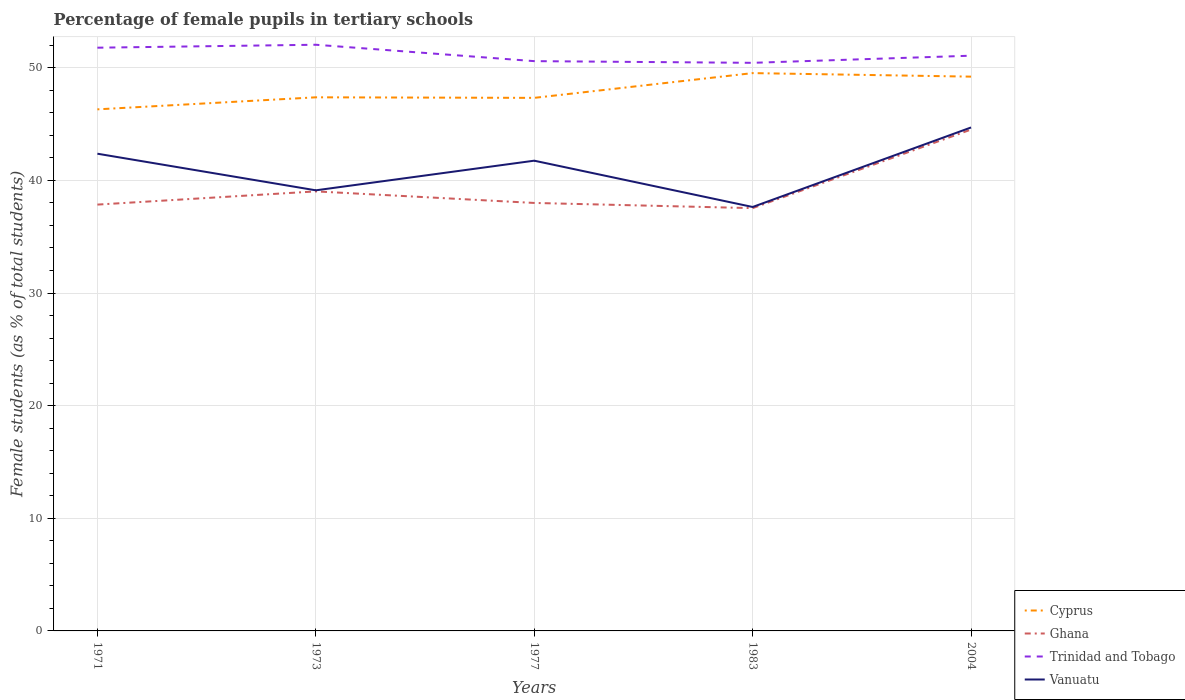Does the line corresponding to Ghana intersect with the line corresponding to Vanuatu?
Your response must be concise. No. Is the number of lines equal to the number of legend labels?
Your answer should be very brief. Yes. Across all years, what is the maximum percentage of female pupils in tertiary schools in Vanuatu?
Keep it short and to the point. 37.64. In which year was the percentage of female pupils in tertiary schools in Ghana maximum?
Give a very brief answer. 1983. What is the total percentage of female pupils in tertiary schools in Cyprus in the graph?
Give a very brief answer. -3.22. What is the difference between the highest and the second highest percentage of female pupils in tertiary schools in Trinidad and Tobago?
Make the answer very short. 1.6. What is the difference between the highest and the lowest percentage of female pupils in tertiary schools in Cyprus?
Provide a short and direct response. 2. Is the percentage of female pupils in tertiary schools in Cyprus strictly greater than the percentage of female pupils in tertiary schools in Ghana over the years?
Keep it short and to the point. No. Where does the legend appear in the graph?
Offer a terse response. Bottom right. What is the title of the graph?
Your answer should be compact. Percentage of female pupils in tertiary schools. Does "Least developed countries" appear as one of the legend labels in the graph?
Your answer should be compact. No. What is the label or title of the Y-axis?
Keep it short and to the point. Female students (as % of total students). What is the Female students (as % of total students) of Cyprus in 1971?
Provide a short and direct response. 46.31. What is the Female students (as % of total students) in Ghana in 1971?
Offer a very short reply. 37.85. What is the Female students (as % of total students) in Trinidad and Tobago in 1971?
Offer a very short reply. 51.78. What is the Female students (as % of total students) in Vanuatu in 1971?
Make the answer very short. 42.37. What is the Female students (as % of total students) of Cyprus in 1973?
Give a very brief answer. 47.38. What is the Female students (as % of total students) of Ghana in 1973?
Give a very brief answer. 39.02. What is the Female students (as % of total students) of Trinidad and Tobago in 1973?
Provide a short and direct response. 52.04. What is the Female students (as % of total students) of Vanuatu in 1973?
Your response must be concise. 39.12. What is the Female students (as % of total students) of Cyprus in 1977?
Your answer should be very brief. 47.33. What is the Female students (as % of total students) of Ghana in 1977?
Offer a very short reply. 38. What is the Female students (as % of total students) of Trinidad and Tobago in 1977?
Your answer should be very brief. 50.59. What is the Female students (as % of total students) of Vanuatu in 1977?
Your answer should be compact. 41.75. What is the Female students (as % of total students) in Cyprus in 1983?
Your answer should be compact. 49.53. What is the Female students (as % of total students) of Ghana in 1983?
Your answer should be compact. 37.54. What is the Female students (as % of total students) of Trinidad and Tobago in 1983?
Your answer should be very brief. 50.44. What is the Female students (as % of total students) in Vanuatu in 1983?
Make the answer very short. 37.64. What is the Female students (as % of total students) of Cyprus in 2004?
Your answer should be compact. 49.21. What is the Female students (as % of total students) in Ghana in 2004?
Make the answer very short. 44.51. What is the Female students (as % of total students) in Trinidad and Tobago in 2004?
Your response must be concise. 51.07. What is the Female students (as % of total students) in Vanuatu in 2004?
Offer a terse response. 44.7. Across all years, what is the maximum Female students (as % of total students) of Cyprus?
Your answer should be compact. 49.53. Across all years, what is the maximum Female students (as % of total students) in Ghana?
Make the answer very short. 44.51. Across all years, what is the maximum Female students (as % of total students) in Trinidad and Tobago?
Offer a terse response. 52.04. Across all years, what is the maximum Female students (as % of total students) in Vanuatu?
Ensure brevity in your answer.  44.7. Across all years, what is the minimum Female students (as % of total students) of Cyprus?
Your answer should be very brief. 46.31. Across all years, what is the minimum Female students (as % of total students) in Ghana?
Provide a short and direct response. 37.54. Across all years, what is the minimum Female students (as % of total students) of Trinidad and Tobago?
Your answer should be very brief. 50.44. Across all years, what is the minimum Female students (as % of total students) in Vanuatu?
Offer a very short reply. 37.64. What is the total Female students (as % of total students) in Cyprus in the graph?
Ensure brevity in your answer.  239.75. What is the total Female students (as % of total students) in Ghana in the graph?
Make the answer very short. 196.92. What is the total Female students (as % of total students) in Trinidad and Tobago in the graph?
Your answer should be very brief. 255.92. What is the total Female students (as % of total students) of Vanuatu in the graph?
Ensure brevity in your answer.  205.57. What is the difference between the Female students (as % of total students) of Cyprus in 1971 and that in 1973?
Your answer should be very brief. -1.07. What is the difference between the Female students (as % of total students) of Ghana in 1971 and that in 1973?
Your answer should be very brief. -1.17. What is the difference between the Female students (as % of total students) in Trinidad and Tobago in 1971 and that in 1973?
Give a very brief answer. -0.26. What is the difference between the Female students (as % of total students) in Vanuatu in 1971 and that in 1973?
Offer a very short reply. 3.25. What is the difference between the Female students (as % of total students) in Cyprus in 1971 and that in 1977?
Provide a succinct answer. -1.02. What is the difference between the Female students (as % of total students) in Ghana in 1971 and that in 1977?
Keep it short and to the point. -0.15. What is the difference between the Female students (as % of total students) of Trinidad and Tobago in 1971 and that in 1977?
Ensure brevity in your answer.  1.19. What is the difference between the Female students (as % of total students) of Vanuatu in 1971 and that in 1977?
Keep it short and to the point. 0.62. What is the difference between the Female students (as % of total students) of Cyprus in 1971 and that in 1983?
Ensure brevity in your answer.  -3.22. What is the difference between the Female students (as % of total students) of Ghana in 1971 and that in 1983?
Your response must be concise. 0.31. What is the difference between the Female students (as % of total students) in Trinidad and Tobago in 1971 and that in 1983?
Offer a terse response. 1.34. What is the difference between the Female students (as % of total students) in Vanuatu in 1971 and that in 1983?
Provide a succinct answer. 4.73. What is the difference between the Female students (as % of total students) of Cyprus in 1971 and that in 2004?
Give a very brief answer. -2.9. What is the difference between the Female students (as % of total students) in Ghana in 1971 and that in 2004?
Your answer should be compact. -6.66. What is the difference between the Female students (as % of total students) in Trinidad and Tobago in 1971 and that in 2004?
Offer a very short reply. 0.71. What is the difference between the Female students (as % of total students) of Vanuatu in 1971 and that in 2004?
Provide a short and direct response. -2.33. What is the difference between the Female students (as % of total students) of Cyprus in 1973 and that in 1977?
Your response must be concise. 0.05. What is the difference between the Female students (as % of total students) of Ghana in 1973 and that in 1977?
Make the answer very short. 1.03. What is the difference between the Female students (as % of total students) in Trinidad and Tobago in 1973 and that in 1977?
Offer a very short reply. 1.46. What is the difference between the Female students (as % of total students) in Vanuatu in 1973 and that in 1977?
Keep it short and to the point. -2.63. What is the difference between the Female students (as % of total students) of Cyprus in 1973 and that in 1983?
Make the answer very short. -2.15. What is the difference between the Female students (as % of total students) in Ghana in 1973 and that in 1983?
Keep it short and to the point. 1.49. What is the difference between the Female students (as % of total students) in Trinidad and Tobago in 1973 and that in 1983?
Make the answer very short. 1.6. What is the difference between the Female students (as % of total students) in Vanuatu in 1973 and that in 1983?
Your answer should be very brief. 1.48. What is the difference between the Female students (as % of total students) in Cyprus in 1973 and that in 2004?
Offer a terse response. -1.84. What is the difference between the Female students (as % of total students) of Ghana in 1973 and that in 2004?
Your answer should be compact. -5.49. What is the difference between the Female students (as % of total students) in Trinidad and Tobago in 1973 and that in 2004?
Offer a very short reply. 0.97. What is the difference between the Female students (as % of total students) of Vanuatu in 1973 and that in 2004?
Your answer should be very brief. -5.58. What is the difference between the Female students (as % of total students) in Cyprus in 1977 and that in 1983?
Offer a terse response. -2.2. What is the difference between the Female students (as % of total students) of Ghana in 1977 and that in 1983?
Keep it short and to the point. 0.46. What is the difference between the Female students (as % of total students) in Trinidad and Tobago in 1977 and that in 1983?
Ensure brevity in your answer.  0.15. What is the difference between the Female students (as % of total students) in Vanuatu in 1977 and that in 1983?
Offer a terse response. 4.11. What is the difference between the Female students (as % of total students) in Cyprus in 1977 and that in 2004?
Ensure brevity in your answer.  -1.88. What is the difference between the Female students (as % of total students) in Ghana in 1977 and that in 2004?
Your answer should be very brief. -6.52. What is the difference between the Female students (as % of total students) in Trinidad and Tobago in 1977 and that in 2004?
Your answer should be compact. -0.48. What is the difference between the Female students (as % of total students) in Vanuatu in 1977 and that in 2004?
Your response must be concise. -2.95. What is the difference between the Female students (as % of total students) in Cyprus in 1983 and that in 2004?
Keep it short and to the point. 0.31. What is the difference between the Female students (as % of total students) of Ghana in 1983 and that in 2004?
Keep it short and to the point. -6.98. What is the difference between the Female students (as % of total students) in Trinidad and Tobago in 1983 and that in 2004?
Provide a short and direct response. -0.63. What is the difference between the Female students (as % of total students) of Vanuatu in 1983 and that in 2004?
Offer a terse response. -7.06. What is the difference between the Female students (as % of total students) in Cyprus in 1971 and the Female students (as % of total students) in Ghana in 1973?
Keep it short and to the point. 7.28. What is the difference between the Female students (as % of total students) of Cyprus in 1971 and the Female students (as % of total students) of Trinidad and Tobago in 1973?
Offer a terse response. -5.74. What is the difference between the Female students (as % of total students) in Cyprus in 1971 and the Female students (as % of total students) in Vanuatu in 1973?
Provide a short and direct response. 7.19. What is the difference between the Female students (as % of total students) in Ghana in 1971 and the Female students (as % of total students) in Trinidad and Tobago in 1973?
Provide a succinct answer. -14.19. What is the difference between the Female students (as % of total students) in Ghana in 1971 and the Female students (as % of total students) in Vanuatu in 1973?
Offer a terse response. -1.27. What is the difference between the Female students (as % of total students) in Trinidad and Tobago in 1971 and the Female students (as % of total students) in Vanuatu in 1973?
Your answer should be very brief. 12.66. What is the difference between the Female students (as % of total students) of Cyprus in 1971 and the Female students (as % of total students) of Ghana in 1977?
Your response must be concise. 8.31. What is the difference between the Female students (as % of total students) of Cyprus in 1971 and the Female students (as % of total students) of Trinidad and Tobago in 1977?
Your answer should be compact. -4.28. What is the difference between the Female students (as % of total students) in Cyprus in 1971 and the Female students (as % of total students) in Vanuatu in 1977?
Offer a terse response. 4.56. What is the difference between the Female students (as % of total students) of Ghana in 1971 and the Female students (as % of total students) of Trinidad and Tobago in 1977?
Your answer should be compact. -12.74. What is the difference between the Female students (as % of total students) in Ghana in 1971 and the Female students (as % of total students) in Vanuatu in 1977?
Offer a very short reply. -3.9. What is the difference between the Female students (as % of total students) of Trinidad and Tobago in 1971 and the Female students (as % of total students) of Vanuatu in 1977?
Offer a terse response. 10.03. What is the difference between the Female students (as % of total students) of Cyprus in 1971 and the Female students (as % of total students) of Ghana in 1983?
Keep it short and to the point. 8.77. What is the difference between the Female students (as % of total students) of Cyprus in 1971 and the Female students (as % of total students) of Trinidad and Tobago in 1983?
Offer a terse response. -4.13. What is the difference between the Female students (as % of total students) of Cyprus in 1971 and the Female students (as % of total students) of Vanuatu in 1983?
Ensure brevity in your answer.  8.67. What is the difference between the Female students (as % of total students) in Ghana in 1971 and the Female students (as % of total students) in Trinidad and Tobago in 1983?
Ensure brevity in your answer.  -12.59. What is the difference between the Female students (as % of total students) in Ghana in 1971 and the Female students (as % of total students) in Vanuatu in 1983?
Keep it short and to the point. 0.21. What is the difference between the Female students (as % of total students) of Trinidad and Tobago in 1971 and the Female students (as % of total students) of Vanuatu in 1983?
Your answer should be very brief. 14.14. What is the difference between the Female students (as % of total students) of Cyprus in 1971 and the Female students (as % of total students) of Ghana in 2004?
Keep it short and to the point. 1.79. What is the difference between the Female students (as % of total students) in Cyprus in 1971 and the Female students (as % of total students) in Trinidad and Tobago in 2004?
Offer a very short reply. -4.76. What is the difference between the Female students (as % of total students) in Cyprus in 1971 and the Female students (as % of total students) in Vanuatu in 2004?
Your response must be concise. 1.61. What is the difference between the Female students (as % of total students) of Ghana in 1971 and the Female students (as % of total students) of Trinidad and Tobago in 2004?
Provide a short and direct response. -13.22. What is the difference between the Female students (as % of total students) in Ghana in 1971 and the Female students (as % of total students) in Vanuatu in 2004?
Make the answer very short. -6.85. What is the difference between the Female students (as % of total students) of Trinidad and Tobago in 1971 and the Female students (as % of total students) of Vanuatu in 2004?
Your answer should be very brief. 7.08. What is the difference between the Female students (as % of total students) of Cyprus in 1973 and the Female students (as % of total students) of Ghana in 1977?
Provide a succinct answer. 9.38. What is the difference between the Female students (as % of total students) in Cyprus in 1973 and the Female students (as % of total students) in Trinidad and Tobago in 1977?
Offer a terse response. -3.21. What is the difference between the Female students (as % of total students) of Cyprus in 1973 and the Female students (as % of total students) of Vanuatu in 1977?
Your answer should be compact. 5.63. What is the difference between the Female students (as % of total students) of Ghana in 1973 and the Female students (as % of total students) of Trinidad and Tobago in 1977?
Your response must be concise. -11.56. What is the difference between the Female students (as % of total students) of Ghana in 1973 and the Female students (as % of total students) of Vanuatu in 1977?
Provide a short and direct response. -2.73. What is the difference between the Female students (as % of total students) of Trinidad and Tobago in 1973 and the Female students (as % of total students) of Vanuatu in 1977?
Provide a succinct answer. 10.29. What is the difference between the Female students (as % of total students) of Cyprus in 1973 and the Female students (as % of total students) of Ghana in 1983?
Give a very brief answer. 9.84. What is the difference between the Female students (as % of total students) of Cyprus in 1973 and the Female students (as % of total students) of Trinidad and Tobago in 1983?
Your answer should be very brief. -3.06. What is the difference between the Female students (as % of total students) in Cyprus in 1973 and the Female students (as % of total students) in Vanuatu in 1983?
Offer a very short reply. 9.74. What is the difference between the Female students (as % of total students) in Ghana in 1973 and the Female students (as % of total students) in Trinidad and Tobago in 1983?
Give a very brief answer. -11.41. What is the difference between the Female students (as % of total students) in Ghana in 1973 and the Female students (as % of total students) in Vanuatu in 1983?
Your answer should be very brief. 1.39. What is the difference between the Female students (as % of total students) in Trinidad and Tobago in 1973 and the Female students (as % of total students) in Vanuatu in 1983?
Give a very brief answer. 14.4. What is the difference between the Female students (as % of total students) of Cyprus in 1973 and the Female students (as % of total students) of Ghana in 2004?
Offer a very short reply. 2.86. What is the difference between the Female students (as % of total students) in Cyprus in 1973 and the Female students (as % of total students) in Trinidad and Tobago in 2004?
Offer a very short reply. -3.7. What is the difference between the Female students (as % of total students) in Cyprus in 1973 and the Female students (as % of total students) in Vanuatu in 2004?
Your answer should be very brief. 2.68. What is the difference between the Female students (as % of total students) of Ghana in 1973 and the Female students (as % of total students) of Trinidad and Tobago in 2004?
Give a very brief answer. -12.05. What is the difference between the Female students (as % of total students) of Ghana in 1973 and the Female students (as % of total students) of Vanuatu in 2004?
Provide a succinct answer. -5.68. What is the difference between the Female students (as % of total students) in Trinidad and Tobago in 1973 and the Female students (as % of total students) in Vanuatu in 2004?
Offer a terse response. 7.34. What is the difference between the Female students (as % of total students) in Cyprus in 1977 and the Female students (as % of total students) in Ghana in 1983?
Make the answer very short. 9.79. What is the difference between the Female students (as % of total students) in Cyprus in 1977 and the Female students (as % of total students) in Trinidad and Tobago in 1983?
Your response must be concise. -3.11. What is the difference between the Female students (as % of total students) in Cyprus in 1977 and the Female students (as % of total students) in Vanuatu in 1983?
Your response must be concise. 9.69. What is the difference between the Female students (as % of total students) of Ghana in 1977 and the Female students (as % of total students) of Trinidad and Tobago in 1983?
Provide a short and direct response. -12.44. What is the difference between the Female students (as % of total students) in Ghana in 1977 and the Female students (as % of total students) in Vanuatu in 1983?
Offer a very short reply. 0.36. What is the difference between the Female students (as % of total students) in Trinidad and Tobago in 1977 and the Female students (as % of total students) in Vanuatu in 1983?
Keep it short and to the point. 12.95. What is the difference between the Female students (as % of total students) in Cyprus in 1977 and the Female students (as % of total students) in Ghana in 2004?
Your answer should be compact. 2.81. What is the difference between the Female students (as % of total students) of Cyprus in 1977 and the Female students (as % of total students) of Trinidad and Tobago in 2004?
Make the answer very short. -3.74. What is the difference between the Female students (as % of total students) in Cyprus in 1977 and the Female students (as % of total students) in Vanuatu in 2004?
Give a very brief answer. 2.63. What is the difference between the Female students (as % of total students) of Ghana in 1977 and the Female students (as % of total students) of Trinidad and Tobago in 2004?
Offer a terse response. -13.07. What is the difference between the Female students (as % of total students) of Ghana in 1977 and the Female students (as % of total students) of Vanuatu in 2004?
Make the answer very short. -6.7. What is the difference between the Female students (as % of total students) of Trinidad and Tobago in 1977 and the Female students (as % of total students) of Vanuatu in 2004?
Provide a succinct answer. 5.89. What is the difference between the Female students (as % of total students) of Cyprus in 1983 and the Female students (as % of total students) of Ghana in 2004?
Offer a very short reply. 5.01. What is the difference between the Female students (as % of total students) of Cyprus in 1983 and the Female students (as % of total students) of Trinidad and Tobago in 2004?
Ensure brevity in your answer.  -1.55. What is the difference between the Female students (as % of total students) in Cyprus in 1983 and the Female students (as % of total students) in Vanuatu in 2004?
Your answer should be very brief. 4.83. What is the difference between the Female students (as % of total students) in Ghana in 1983 and the Female students (as % of total students) in Trinidad and Tobago in 2004?
Your answer should be very brief. -13.53. What is the difference between the Female students (as % of total students) of Ghana in 1983 and the Female students (as % of total students) of Vanuatu in 2004?
Offer a terse response. -7.16. What is the difference between the Female students (as % of total students) in Trinidad and Tobago in 1983 and the Female students (as % of total students) in Vanuatu in 2004?
Your answer should be compact. 5.74. What is the average Female students (as % of total students) of Cyprus per year?
Make the answer very short. 47.95. What is the average Female students (as % of total students) in Ghana per year?
Offer a very short reply. 39.38. What is the average Female students (as % of total students) in Trinidad and Tobago per year?
Offer a terse response. 51.18. What is the average Female students (as % of total students) in Vanuatu per year?
Give a very brief answer. 41.11. In the year 1971, what is the difference between the Female students (as % of total students) of Cyprus and Female students (as % of total students) of Ghana?
Provide a short and direct response. 8.46. In the year 1971, what is the difference between the Female students (as % of total students) of Cyprus and Female students (as % of total students) of Trinidad and Tobago?
Give a very brief answer. -5.47. In the year 1971, what is the difference between the Female students (as % of total students) in Cyprus and Female students (as % of total students) in Vanuatu?
Your answer should be very brief. 3.94. In the year 1971, what is the difference between the Female students (as % of total students) of Ghana and Female students (as % of total students) of Trinidad and Tobago?
Provide a short and direct response. -13.93. In the year 1971, what is the difference between the Female students (as % of total students) of Ghana and Female students (as % of total students) of Vanuatu?
Keep it short and to the point. -4.52. In the year 1971, what is the difference between the Female students (as % of total students) of Trinidad and Tobago and Female students (as % of total students) of Vanuatu?
Your answer should be compact. 9.41. In the year 1973, what is the difference between the Female students (as % of total students) in Cyprus and Female students (as % of total students) in Ghana?
Ensure brevity in your answer.  8.35. In the year 1973, what is the difference between the Female students (as % of total students) of Cyprus and Female students (as % of total students) of Trinidad and Tobago?
Ensure brevity in your answer.  -4.67. In the year 1973, what is the difference between the Female students (as % of total students) of Cyprus and Female students (as % of total students) of Vanuatu?
Offer a very short reply. 8.26. In the year 1973, what is the difference between the Female students (as % of total students) in Ghana and Female students (as % of total students) in Trinidad and Tobago?
Give a very brief answer. -13.02. In the year 1973, what is the difference between the Female students (as % of total students) of Ghana and Female students (as % of total students) of Vanuatu?
Offer a terse response. -0.1. In the year 1973, what is the difference between the Female students (as % of total students) in Trinidad and Tobago and Female students (as % of total students) in Vanuatu?
Keep it short and to the point. 12.92. In the year 1977, what is the difference between the Female students (as % of total students) in Cyprus and Female students (as % of total students) in Ghana?
Keep it short and to the point. 9.33. In the year 1977, what is the difference between the Female students (as % of total students) in Cyprus and Female students (as % of total students) in Trinidad and Tobago?
Keep it short and to the point. -3.26. In the year 1977, what is the difference between the Female students (as % of total students) of Cyprus and Female students (as % of total students) of Vanuatu?
Offer a terse response. 5.58. In the year 1977, what is the difference between the Female students (as % of total students) in Ghana and Female students (as % of total students) in Trinidad and Tobago?
Give a very brief answer. -12.59. In the year 1977, what is the difference between the Female students (as % of total students) of Ghana and Female students (as % of total students) of Vanuatu?
Your response must be concise. -3.75. In the year 1977, what is the difference between the Female students (as % of total students) of Trinidad and Tobago and Female students (as % of total students) of Vanuatu?
Your answer should be very brief. 8.84. In the year 1983, what is the difference between the Female students (as % of total students) in Cyprus and Female students (as % of total students) in Ghana?
Offer a terse response. 11.99. In the year 1983, what is the difference between the Female students (as % of total students) in Cyprus and Female students (as % of total students) in Trinidad and Tobago?
Provide a succinct answer. -0.91. In the year 1983, what is the difference between the Female students (as % of total students) in Cyprus and Female students (as % of total students) in Vanuatu?
Offer a terse response. 11.89. In the year 1983, what is the difference between the Female students (as % of total students) of Ghana and Female students (as % of total students) of Trinidad and Tobago?
Your answer should be very brief. -12.9. In the year 1983, what is the difference between the Female students (as % of total students) in Ghana and Female students (as % of total students) in Vanuatu?
Your answer should be compact. -0.1. In the year 1983, what is the difference between the Female students (as % of total students) in Trinidad and Tobago and Female students (as % of total students) in Vanuatu?
Make the answer very short. 12.8. In the year 2004, what is the difference between the Female students (as % of total students) in Cyprus and Female students (as % of total students) in Ghana?
Provide a short and direct response. 4.7. In the year 2004, what is the difference between the Female students (as % of total students) of Cyprus and Female students (as % of total students) of Trinidad and Tobago?
Offer a terse response. -1.86. In the year 2004, what is the difference between the Female students (as % of total students) in Cyprus and Female students (as % of total students) in Vanuatu?
Provide a succinct answer. 4.51. In the year 2004, what is the difference between the Female students (as % of total students) of Ghana and Female students (as % of total students) of Trinidad and Tobago?
Keep it short and to the point. -6.56. In the year 2004, what is the difference between the Female students (as % of total students) of Ghana and Female students (as % of total students) of Vanuatu?
Give a very brief answer. -0.19. In the year 2004, what is the difference between the Female students (as % of total students) of Trinidad and Tobago and Female students (as % of total students) of Vanuatu?
Ensure brevity in your answer.  6.37. What is the ratio of the Female students (as % of total students) in Cyprus in 1971 to that in 1973?
Give a very brief answer. 0.98. What is the ratio of the Female students (as % of total students) of Ghana in 1971 to that in 1973?
Keep it short and to the point. 0.97. What is the ratio of the Female students (as % of total students) of Trinidad and Tobago in 1971 to that in 1973?
Ensure brevity in your answer.  0.99. What is the ratio of the Female students (as % of total students) of Vanuatu in 1971 to that in 1973?
Offer a very short reply. 1.08. What is the ratio of the Female students (as % of total students) in Cyprus in 1971 to that in 1977?
Provide a short and direct response. 0.98. What is the ratio of the Female students (as % of total students) in Trinidad and Tobago in 1971 to that in 1977?
Make the answer very short. 1.02. What is the ratio of the Female students (as % of total students) in Vanuatu in 1971 to that in 1977?
Offer a very short reply. 1.01. What is the ratio of the Female students (as % of total students) in Cyprus in 1971 to that in 1983?
Keep it short and to the point. 0.94. What is the ratio of the Female students (as % of total students) of Ghana in 1971 to that in 1983?
Make the answer very short. 1.01. What is the ratio of the Female students (as % of total students) of Trinidad and Tobago in 1971 to that in 1983?
Provide a succinct answer. 1.03. What is the ratio of the Female students (as % of total students) in Vanuatu in 1971 to that in 1983?
Provide a succinct answer. 1.13. What is the ratio of the Female students (as % of total students) of Cyprus in 1971 to that in 2004?
Your answer should be compact. 0.94. What is the ratio of the Female students (as % of total students) of Ghana in 1971 to that in 2004?
Give a very brief answer. 0.85. What is the ratio of the Female students (as % of total students) of Trinidad and Tobago in 1971 to that in 2004?
Ensure brevity in your answer.  1.01. What is the ratio of the Female students (as % of total students) in Vanuatu in 1971 to that in 2004?
Make the answer very short. 0.95. What is the ratio of the Female students (as % of total students) in Cyprus in 1973 to that in 1977?
Ensure brevity in your answer.  1. What is the ratio of the Female students (as % of total students) in Trinidad and Tobago in 1973 to that in 1977?
Give a very brief answer. 1.03. What is the ratio of the Female students (as % of total students) in Vanuatu in 1973 to that in 1977?
Your answer should be compact. 0.94. What is the ratio of the Female students (as % of total students) in Cyprus in 1973 to that in 1983?
Offer a terse response. 0.96. What is the ratio of the Female students (as % of total students) in Ghana in 1973 to that in 1983?
Your answer should be compact. 1.04. What is the ratio of the Female students (as % of total students) of Trinidad and Tobago in 1973 to that in 1983?
Your answer should be compact. 1.03. What is the ratio of the Female students (as % of total students) of Vanuatu in 1973 to that in 1983?
Provide a short and direct response. 1.04. What is the ratio of the Female students (as % of total students) of Cyprus in 1973 to that in 2004?
Ensure brevity in your answer.  0.96. What is the ratio of the Female students (as % of total students) of Ghana in 1973 to that in 2004?
Make the answer very short. 0.88. What is the ratio of the Female students (as % of total students) of Vanuatu in 1973 to that in 2004?
Make the answer very short. 0.88. What is the ratio of the Female students (as % of total students) of Cyprus in 1977 to that in 1983?
Your response must be concise. 0.96. What is the ratio of the Female students (as % of total students) in Ghana in 1977 to that in 1983?
Your answer should be very brief. 1.01. What is the ratio of the Female students (as % of total students) of Trinidad and Tobago in 1977 to that in 1983?
Your response must be concise. 1. What is the ratio of the Female students (as % of total students) of Vanuatu in 1977 to that in 1983?
Your response must be concise. 1.11. What is the ratio of the Female students (as % of total students) of Cyprus in 1977 to that in 2004?
Offer a very short reply. 0.96. What is the ratio of the Female students (as % of total students) in Ghana in 1977 to that in 2004?
Offer a very short reply. 0.85. What is the ratio of the Female students (as % of total students) in Trinidad and Tobago in 1977 to that in 2004?
Offer a very short reply. 0.99. What is the ratio of the Female students (as % of total students) in Vanuatu in 1977 to that in 2004?
Give a very brief answer. 0.93. What is the ratio of the Female students (as % of total students) of Cyprus in 1983 to that in 2004?
Give a very brief answer. 1.01. What is the ratio of the Female students (as % of total students) of Ghana in 1983 to that in 2004?
Provide a short and direct response. 0.84. What is the ratio of the Female students (as % of total students) in Trinidad and Tobago in 1983 to that in 2004?
Make the answer very short. 0.99. What is the ratio of the Female students (as % of total students) of Vanuatu in 1983 to that in 2004?
Provide a short and direct response. 0.84. What is the difference between the highest and the second highest Female students (as % of total students) of Cyprus?
Your answer should be compact. 0.31. What is the difference between the highest and the second highest Female students (as % of total students) of Ghana?
Ensure brevity in your answer.  5.49. What is the difference between the highest and the second highest Female students (as % of total students) of Trinidad and Tobago?
Provide a short and direct response. 0.26. What is the difference between the highest and the second highest Female students (as % of total students) of Vanuatu?
Offer a terse response. 2.33. What is the difference between the highest and the lowest Female students (as % of total students) of Cyprus?
Your response must be concise. 3.22. What is the difference between the highest and the lowest Female students (as % of total students) in Ghana?
Your response must be concise. 6.98. What is the difference between the highest and the lowest Female students (as % of total students) in Trinidad and Tobago?
Make the answer very short. 1.6. What is the difference between the highest and the lowest Female students (as % of total students) of Vanuatu?
Your answer should be compact. 7.06. 